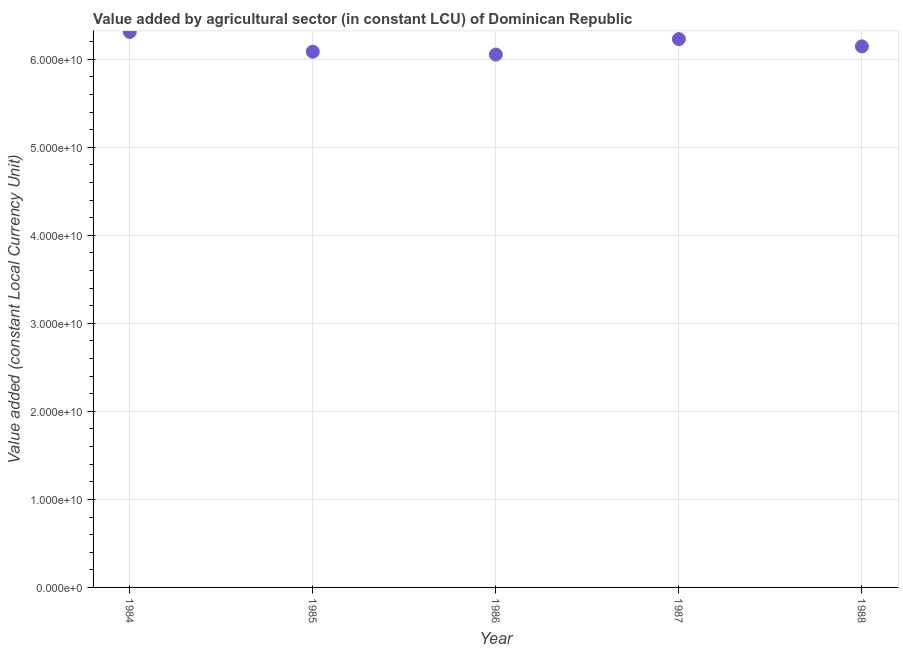What is the value added by agriculture sector in 1986?
Offer a terse response. 6.05e+1. Across all years, what is the maximum value added by agriculture sector?
Give a very brief answer. 6.31e+1. Across all years, what is the minimum value added by agriculture sector?
Give a very brief answer. 6.05e+1. In which year was the value added by agriculture sector maximum?
Give a very brief answer. 1984. What is the sum of the value added by agriculture sector?
Provide a short and direct response. 3.08e+11. What is the difference between the value added by agriculture sector in 1987 and 1988?
Your response must be concise. 8.25e+08. What is the average value added by agriculture sector per year?
Offer a terse response. 6.16e+1. What is the median value added by agriculture sector?
Make the answer very short. 6.15e+1. In how many years, is the value added by agriculture sector greater than 54000000000 LCU?
Keep it short and to the point. 5. What is the ratio of the value added by agriculture sector in 1984 to that in 1988?
Your answer should be compact. 1.03. Is the difference between the value added by agriculture sector in 1986 and 1988 greater than the difference between any two years?
Make the answer very short. No. What is the difference between the highest and the second highest value added by agriculture sector?
Make the answer very short. 8.13e+08. Is the sum of the value added by agriculture sector in 1984 and 1988 greater than the maximum value added by agriculture sector across all years?
Give a very brief answer. Yes. What is the difference between the highest and the lowest value added by agriculture sector?
Keep it short and to the point. 2.57e+09. How many dotlines are there?
Offer a terse response. 1. What is the difference between two consecutive major ticks on the Y-axis?
Your answer should be very brief. 1.00e+1. Are the values on the major ticks of Y-axis written in scientific E-notation?
Keep it short and to the point. Yes. What is the title of the graph?
Make the answer very short. Value added by agricultural sector (in constant LCU) of Dominican Republic. What is the label or title of the Y-axis?
Keep it short and to the point. Value added (constant Local Currency Unit). What is the Value added (constant Local Currency Unit) in 1984?
Offer a very short reply. 6.31e+1. What is the Value added (constant Local Currency Unit) in 1985?
Ensure brevity in your answer.  6.09e+1. What is the Value added (constant Local Currency Unit) in 1986?
Offer a very short reply. 6.05e+1. What is the Value added (constant Local Currency Unit) in 1987?
Your response must be concise. 6.23e+1. What is the Value added (constant Local Currency Unit) in 1988?
Give a very brief answer. 6.15e+1. What is the difference between the Value added (constant Local Currency Unit) in 1984 and 1985?
Your answer should be compact. 2.25e+09. What is the difference between the Value added (constant Local Currency Unit) in 1984 and 1986?
Provide a short and direct response. 2.57e+09. What is the difference between the Value added (constant Local Currency Unit) in 1984 and 1987?
Keep it short and to the point. 8.13e+08. What is the difference between the Value added (constant Local Currency Unit) in 1984 and 1988?
Your answer should be compact. 1.64e+09. What is the difference between the Value added (constant Local Currency Unit) in 1985 and 1986?
Make the answer very short. 3.21e+08. What is the difference between the Value added (constant Local Currency Unit) in 1985 and 1987?
Provide a succinct answer. -1.43e+09. What is the difference between the Value added (constant Local Currency Unit) in 1985 and 1988?
Ensure brevity in your answer.  -6.07e+08. What is the difference between the Value added (constant Local Currency Unit) in 1986 and 1987?
Keep it short and to the point. -1.75e+09. What is the difference between the Value added (constant Local Currency Unit) in 1986 and 1988?
Your answer should be compact. -9.28e+08. What is the difference between the Value added (constant Local Currency Unit) in 1987 and 1988?
Ensure brevity in your answer.  8.25e+08. What is the ratio of the Value added (constant Local Currency Unit) in 1984 to that in 1985?
Keep it short and to the point. 1.04. What is the ratio of the Value added (constant Local Currency Unit) in 1984 to that in 1986?
Provide a short and direct response. 1.04. What is the ratio of the Value added (constant Local Currency Unit) in 1985 to that in 1988?
Make the answer very short. 0.99. 